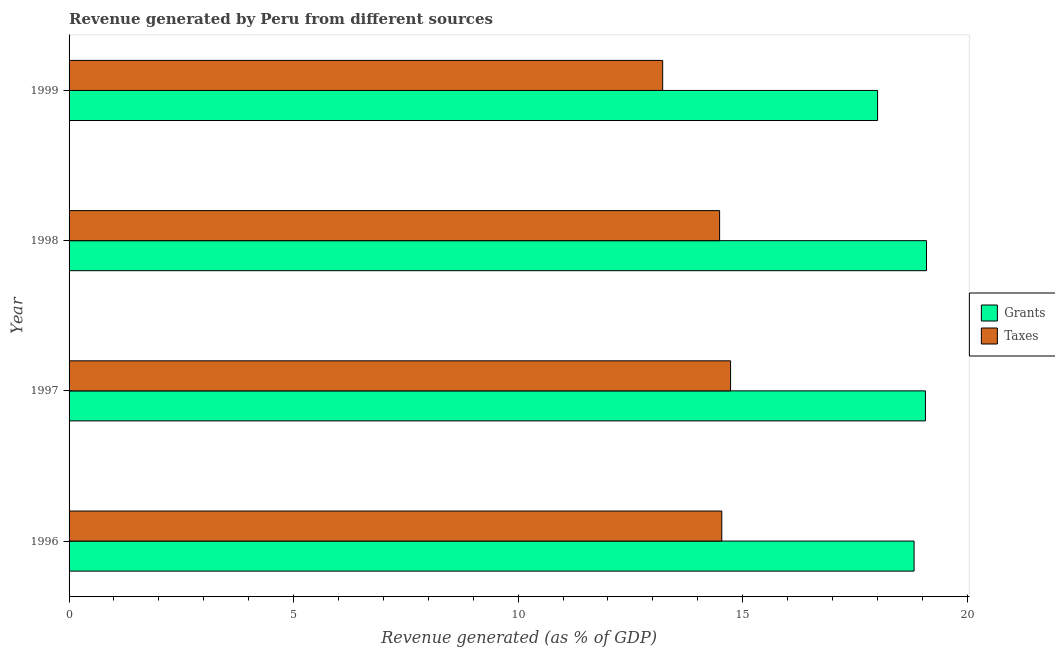Are the number of bars per tick equal to the number of legend labels?
Make the answer very short. Yes. Are the number of bars on each tick of the Y-axis equal?
Provide a succinct answer. Yes. How many bars are there on the 3rd tick from the top?
Offer a very short reply. 2. How many bars are there on the 3rd tick from the bottom?
Your answer should be very brief. 2. In how many cases, is the number of bars for a given year not equal to the number of legend labels?
Your response must be concise. 0. What is the revenue generated by taxes in 1996?
Give a very brief answer. 14.54. Across all years, what is the maximum revenue generated by grants?
Keep it short and to the point. 19.09. Across all years, what is the minimum revenue generated by grants?
Provide a short and direct response. 18.01. In which year was the revenue generated by grants minimum?
Give a very brief answer. 1999. What is the total revenue generated by taxes in the graph?
Keep it short and to the point. 56.97. What is the difference between the revenue generated by taxes in 1996 and that in 1997?
Keep it short and to the point. -0.2. What is the difference between the revenue generated by taxes in 1997 and the revenue generated by grants in 1996?
Your answer should be very brief. -4.09. What is the average revenue generated by grants per year?
Ensure brevity in your answer.  18.75. In the year 1996, what is the difference between the revenue generated by taxes and revenue generated by grants?
Make the answer very short. -4.28. What is the difference between the highest and the second highest revenue generated by taxes?
Ensure brevity in your answer.  0.2. What is the difference between the highest and the lowest revenue generated by grants?
Keep it short and to the point. 1.09. Is the sum of the revenue generated by taxes in 1997 and 1999 greater than the maximum revenue generated by grants across all years?
Give a very brief answer. Yes. What does the 1st bar from the top in 1996 represents?
Provide a short and direct response. Taxes. What does the 1st bar from the bottom in 1997 represents?
Your answer should be very brief. Grants. How many bars are there?
Keep it short and to the point. 8. Does the graph contain any zero values?
Your answer should be very brief. No. Where does the legend appear in the graph?
Your response must be concise. Center right. How are the legend labels stacked?
Provide a short and direct response. Vertical. What is the title of the graph?
Give a very brief answer. Revenue generated by Peru from different sources. What is the label or title of the X-axis?
Your answer should be compact. Revenue generated (as % of GDP). What is the Revenue generated (as % of GDP) in Grants in 1996?
Offer a very short reply. 18.82. What is the Revenue generated (as % of GDP) in Taxes in 1996?
Make the answer very short. 14.54. What is the Revenue generated (as % of GDP) in Grants in 1997?
Offer a very short reply. 19.07. What is the Revenue generated (as % of GDP) in Taxes in 1997?
Give a very brief answer. 14.73. What is the Revenue generated (as % of GDP) in Grants in 1998?
Provide a short and direct response. 19.09. What is the Revenue generated (as % of GDP) in Taxes in 1998?
Ensure brevity in your answer.  14.49. What is the Revenue generated (as % of GDP) of Grants in 1999?
Ensure brevity in your answer.  18.01. What is the Revenue generated (as % of GDP) of Taxes in 1999?
Offer a very short reply. 13.22. Across all years, what is the maximum Revenue generated (as % of GDP) of Grants?
Keep it short and to the point. 19.09. Across all years, what is the maximum Revenue generated (as % of GDP) in Taxes?
Ensure brevity in your answer.  14.73. Across all years, what is the minimum Revenue generated (as % of GDP) of Grants?
Offer a terse response. 18.01. Across all years, what is the minimum Revenue generated (as % of GDP) of Taxes?
Offer a terse response. 13.22. What is the total Revenue generated (as % of GDP) of Grants in the graph?
Your answer should be very brief. 74.99. What is the total Revenue generated (as % of GDP) in Taxes in the graph?
Ensure brevity in your answer.  56.97. What is the difference between the Revenue generated (as % of GDP) in Grants in 1996 and that in 1997?
Your answer should be compact. -0.25. What is the difference between the Revenue generated (as % of GDP) of Taxes in 1996 and that in 1997?
Your response must be concise. -0.2. What is the difference between the Revenue generated (as % of GDP) of Grants in 1996 and that in 1998?
Your response must be concise. -0.28. What is the difference between the Revenue generated (as % of GDP) of Taxes in 1996 and that in 1998?
Provide a succinct answer. 0.05. What is the difference between the Revenue generated (as % of GDP) of Grants in 1996 and that in 1999?
Ensure brevity in your answer.  0.81. What is the difference between the Revenue generated (as % of GDP) of Taxes in 1996 and that in 1999?
Offer a terse response. 1.32. What is the difference between the Revenue generated (as % of GDP) of Grants in 1997 and that in 1998?
Offer a very short reply. -0.02. What is the difference between the Revenue generated (as % of GDP) in Taxes in 1997 and that in 1998?
Provide a succinct answer. 0.24. What is the difference between the Revenue generated (as % of GDP) in Grants in 1997 and that in 1999?
Offer a very short reply. 1.07. What is the difference between the Revenue generated (as % of GDP) of Taxes in 1997 and that in 1999?
Your answer should be very brief. 1.51. What is the difference between the Revenue generated (as % of GDP) in Grants in 1998 and that in 1999?
Your response must be concise. 1.09. What is the difference between the Revenue generated (as % of GDP) of Taxes in 1998 and that in 1999?
Provide a succinct answer. 1.27. What is the difference between the Revenue generated (as % of GDP) in Grants in 1996 and the Revenue generated (as % of GDP) in Taxes in 1997?
Give a very brief answer. 4.09. What is the difference between the Revenue generated (as % of GDP) of Grants in 1996 and the Revenue generated (as % of GDP) of Taxes in 1998?
Your answer should be very brief. 4.33. What is the difference between the Revenue generated (as % of GDP) in Grants in 1996 and the Revenue generated (as % of GDP) in Taxes in 1999?
Provide a short and direct response. 5.6. What is the difference between the Revenue generated (as % of GDP) of Grants in 1997 and the Revenue generated (as % of GDP) of Taxes in 1998?
Make the answer very short. 4.58. What is the difference between the Revenue generated (as % of GDP) of Grants in 1997 and the Revenue generated (as % of GDP) of Taxes in 1999?
Your response must be concise. 5.85. What is the difference between the Revenue generated (as % of GDP) of Grants in 1998 and the Revenue generated (as % of GDP) of Taxes in 1999?
Make the answer very short. 5.88. What is the average Revenue generated (as % of GDP) of Grants per year?
Your answer should be very brief. 18.75. What is the average Revenue generated (as % of GDP) of Taxes per year?
Make the answer very short. 14.24. In the year 1996, what is the difference between the Revenue generated (as % of GDP) of Grants and Revenue generated (as % of GDP) of Taxes?
Ensure brevity in your answer.  4.28. In the year 1997, what is the difference between the Revenue generated (as % of GDP) of Grants and Revenue generated (as % of GDP) of Taxes?
Your answer should be very brief. 4.34. In the year 1998, what is the difference between the Revenue generated (as % of GDP) in Grants and Revenue generated (as % of GDP) in Taxes?
Offer a terse response. 4.61. In the year 1999, what is the difference between the Revenue generated (as % of GDP) in Grants and Revenue generated (as % of GDP) in Taxes?
Give a very brief answer. 4.79. What is the ratio of the Revenue generated (as % of GDP) of Grants in 1996 to that in 1997?
Your answer should be very brief. 0.99. What is the ratio of the Revenue generated (as % of GDP) in Taxes in 1996 to that in 1997?
Make the answer very short. 0.99. What is the ratio of the Revenue generated (as % of GDP) in Grants in 1996 to that in 1998?
Offer a very short reply. 0.99. What is the ratio of the Revenue generated (as % of GDP) of Taxes in 1996 to that in 1998?
Your answer should be very brief. 1. What is the ratio of the Revenue generated (as % of GDP) in Grants in 1996 to that in 1999?
Your response must be concise. 1.05. What is the ratio of the Revenue generated (as % of GDP) in Taxes in 1996 to that in 1999?
Ensure brevity in your answer.  1.1. What is the ratio of the Revenue generated (as % of GDP) of Taxes in 1997 to that in 1998?
Ensure brevity in your answer.  1.02. What is the ratio of the Revenue generated (as % of GDP) in Grants in 1997 to that in 1999?
Give a very brief answer. 1.06. What is the ratio of the Revenue generated (as % of GDP) of Taxes in 1997 to that in 1999?
Give a very brief answer. 1.11. What is the ratio of the Revenue generated (as % of GDP) of Grants in 1998 to that in 1999?
Give a very brief answer. 1.06. What is the ratio of the Revenue generated (as % of GDP) of Taxes in 1998 to that in 1999?
Your answer should be compact. 1.1. What is the difference between the highest and the second highest Revenue generated (as % of GDP) in Grants?
Provide a succinct answer. 0.02. What is the difference between the highest and the second highest Revenue generated (as % of GDP) in Taxes?
Make the answer very short. 0.2. What is the difference between the highest and the lowest Revenue generated (as % of GDP) in Grants?
Provide a short and direct response. 1.09. What is the difference between the highest and the lowest Revenue generated (as % of GDP) in Taxes?
Provide a short and direct response. 1.51. 